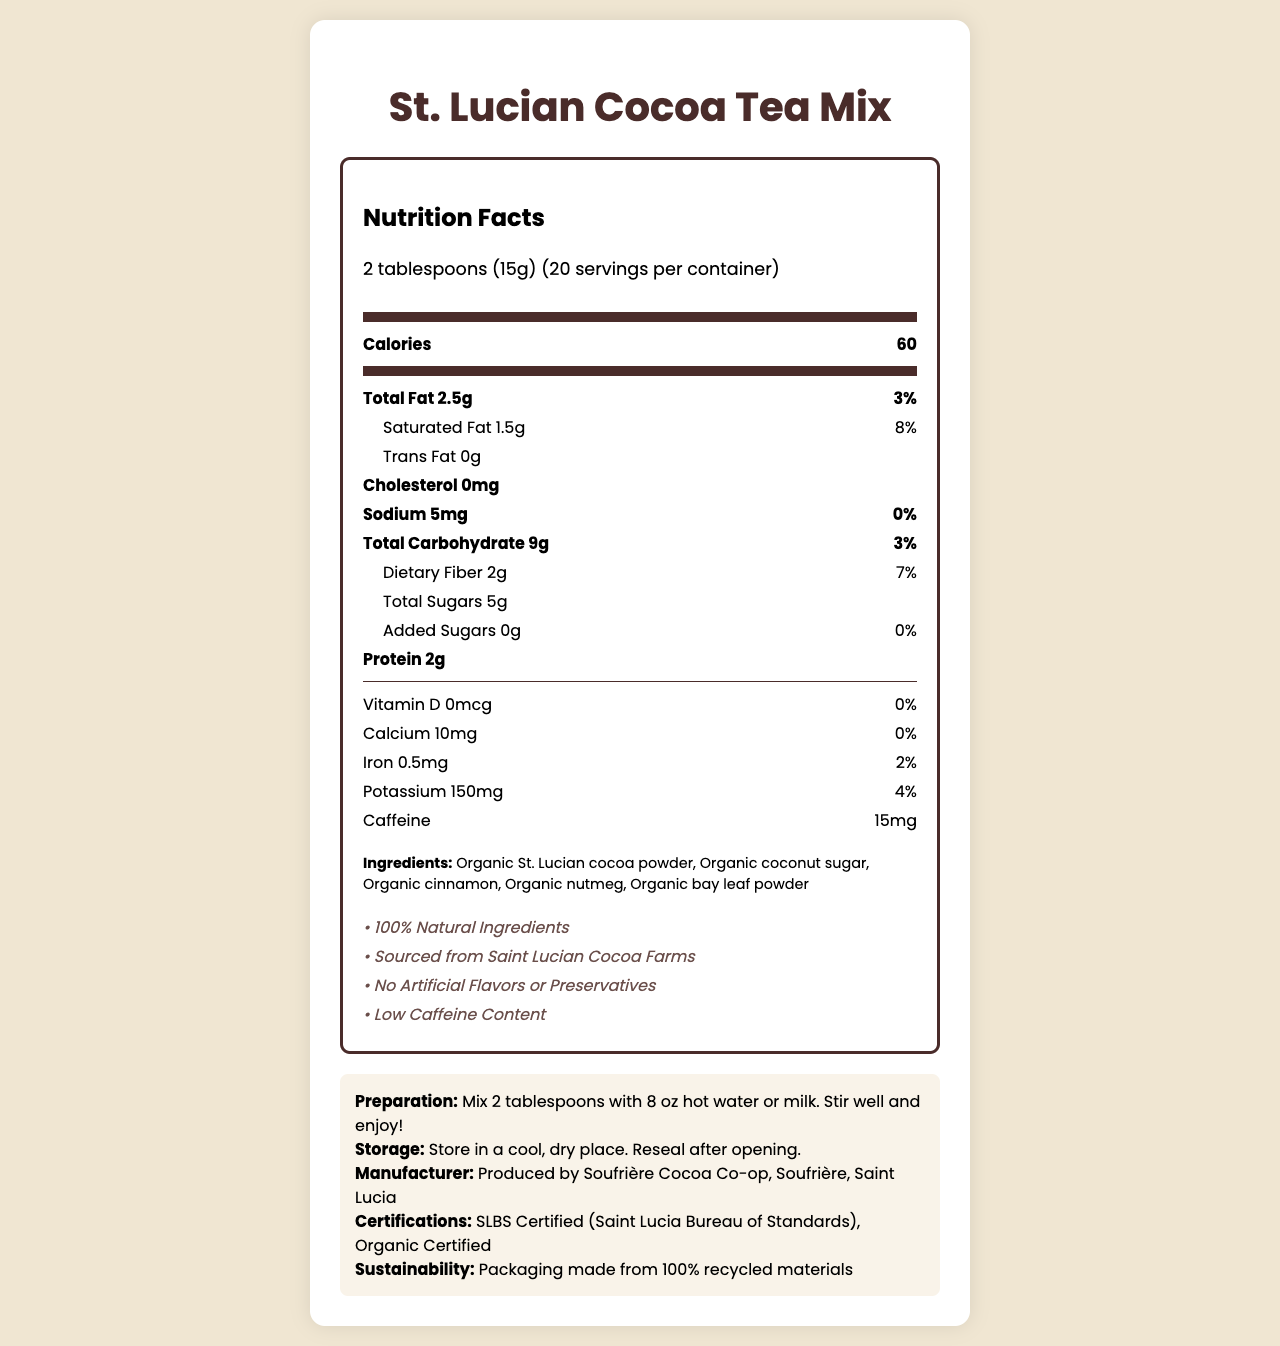How many calories are in one serving of the St. Lucian Cocoa Tea Mix? The nutrition label states that each serving contains 60 calories.
Answer: 60 How much caffeine is in one serving? The label indicates that each serving contains 15mg of caffeine.
Answer: 15mg List three ingredients found in the St. Lucian Cocoa Tea Mix. The ingredients section lists all components, including organic St. Lucian cocoa powder, organic coconut sugar, and organic cinnamon.
Answer: Organic St. Lucian cocoa powder, Organic coconut sugar, Organic cinnamon What is the daily value percentage of dietary fiber per serving? The label shows that the daily value percentage of dietary fiber per serving is 7%.
Answer: 7% What certification does the product have? The document states that the product is SLBS Certified and Organic Certified.
Answer: SLBS Certified (Saint Lucia Bureau of Standards), Organic Certified What is the serving size of the St. Lucian Cocoa Tea Mix? A. 1 tablespoon B. 2 tablespoons C. 3 tablespoons D. 4 tablespoons The nutrition facts specify that the serving size is 2 tablespoons (15g).
Answer: B Which of the following is NOT listed as a main nutrient on the label? I. Total Fat II. Cholesterol III. Vitamin A IV. Caffeine The main nutrients listed are Total Fat, Cholesterol, and Caffeine, but Vitamin A is not mentioned on the label.
Answer: III Is the product labeled as having artificial flavors or preservatives? The claims section indicates that the product has no artificial flavors or preservatives.
Answer: No Summarize the main focus of the document. The document aims to deliver comprehensive nutrition facts and additional qualitative information about the St. Lucian Cocoa Tea Mix, highlighting its health and sustainability benefits.
Answer: The document provides detailed nutritional information about the St. Lucian Cocoa Tea Mix, emphasizing its natural ingredients, low caffeine content, and certifications. It includes specific nutritional values per serving, ingredients, preparation instructions, and manufacturer details. What types of allergens might the product contain? The document mentions that the product is produced in a facility that processes tree nuts and milk products, but it does not conclusively state what specific allergens the product itself might contain.
Answer: Not enough information 